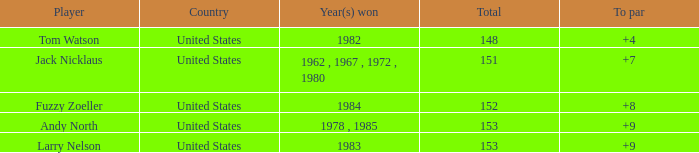What is the To par of the Player wtih Year(s) won of 1983? 9.0. 